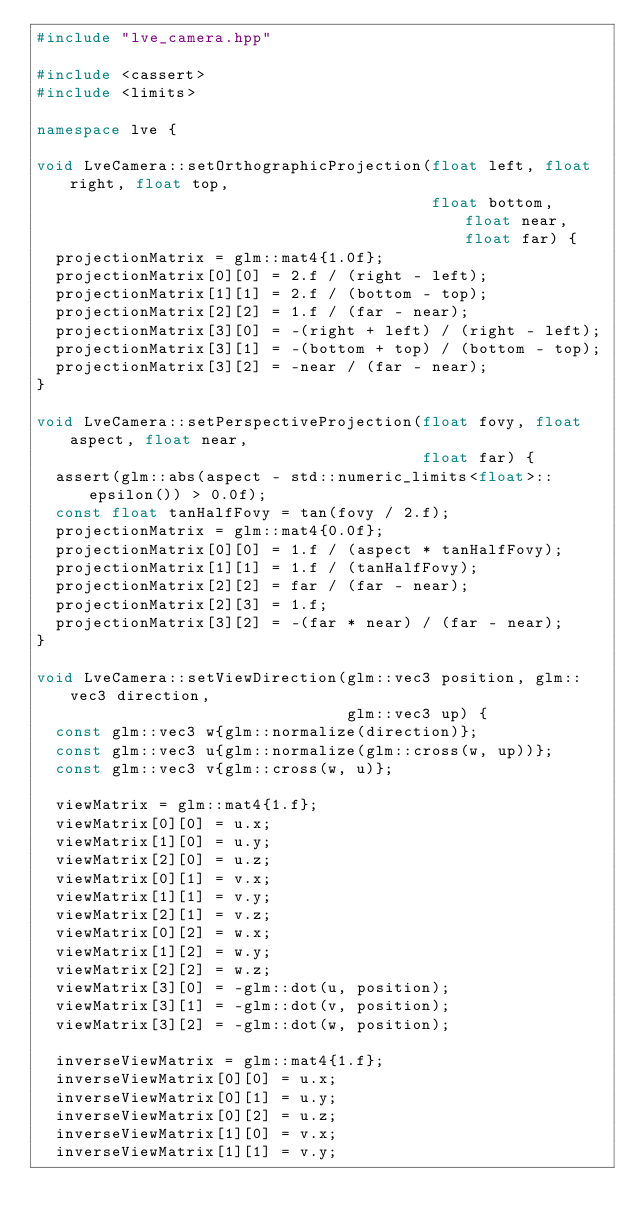<code> <loc_0><loc_0><loc_500><loc_500><_C++_>#include "lve_camera.hpp"

#include <cassert>
#include <limits>

namespace lve {

void LveCamera::setOrthographicProjection(float left, float right, float top,
                                          float bottom, float near, float far) {
  projectionMatrix = glm::mat4{1.0f};
  projectionMatrix[0][0] = 2.f / (right - left);
  projectionMatrix[1][1] = 2.f / (bottom - top);
  projectionMatrix[2][2] = 1.f / (far - near);
  projectionMatrix[3][0] = -(right + left) / (right - left);
  projectionMatrix[3][1] = -(bottom + top) / (bottom - top);
  projectionMatrix[3][2] = -near / (far - near);
}

void LveCamera::setPerspectiveProjection(float fovy, float aspect, float near,
                                         float far) {
  assert(glm::abs(aspect - std::numeric_limits<float>::epsilon()) > 0.0f);
  const float tanHalfFovy = tan(fovy / 2.f);
  projectionMatrix = glm::mat4{0.0f};
  projectionMatrix[0][0] = 1.f / (aspect * tanHalfFovy);
  projectionMatrix[1][1] = 1.f / (tanHalfFovy);
  projectionMatrix[2][2] = far / (far - near);
  projectionMatrix[2][3] = 1.f;
  projectionMatrix[3][2] = -(far * near) / (far - near);
}

void LveCamera::setViewDirection(glm::vec3 position, glm::vec3 direction,
                                 glm::vec3 up) {
  const glm::vec3 w{glm::normalize(direction)};
  const glm::vec3 u{glm::normalize(glm::cross(w, up))};
  const glm::vec3 v{glm::cross(w, u)};

  viewMatrix = glm::mat4{1.f};
  viewMatrix[0][0] = u.x;
  viewMatrix[1][0] = u.y;
  viewMatrix[2][0] = u.z;
  viewMatrix[0][1] = v.x;
  viewMatrix[1][1] = v.y;
  viewMatrix[2][1] = v.z;
  viewMatrix[0][2] = w.x;
  viewMatrix[1][2] = w.y;
  viewMatrix[2][2] = w.z;
  viewMatrix[3][0] = -glm::dot(u, position);
  viewMatrix[3][1] = -glm::dot(v, position);
  viewMatrix[3][2] = -glm::dot(w, position);

  inverseViewMatrix = glm::mat4{1.f};
  inverseViewMatrix[0][0] = u.x;
  inverseViewMatrix[0][1] = u.y;
  inverseViewMatrix[0][2] = u.z;
  inverseViewMatrix[1][0] = v.x;
  inverseViewMatrix[1][1] = v.y;</code> 